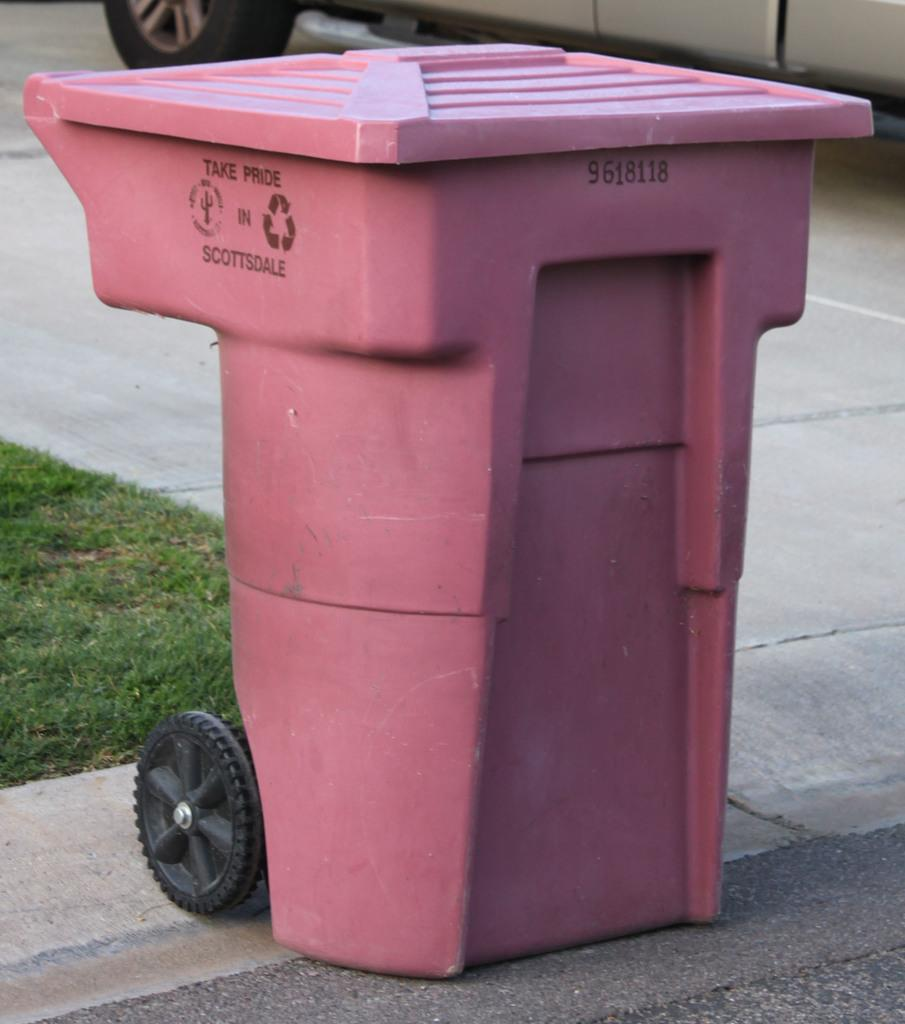<image>
Write a terse but informative summary of the picture. A trash can has Take Pride Scottsdale written on the side. 